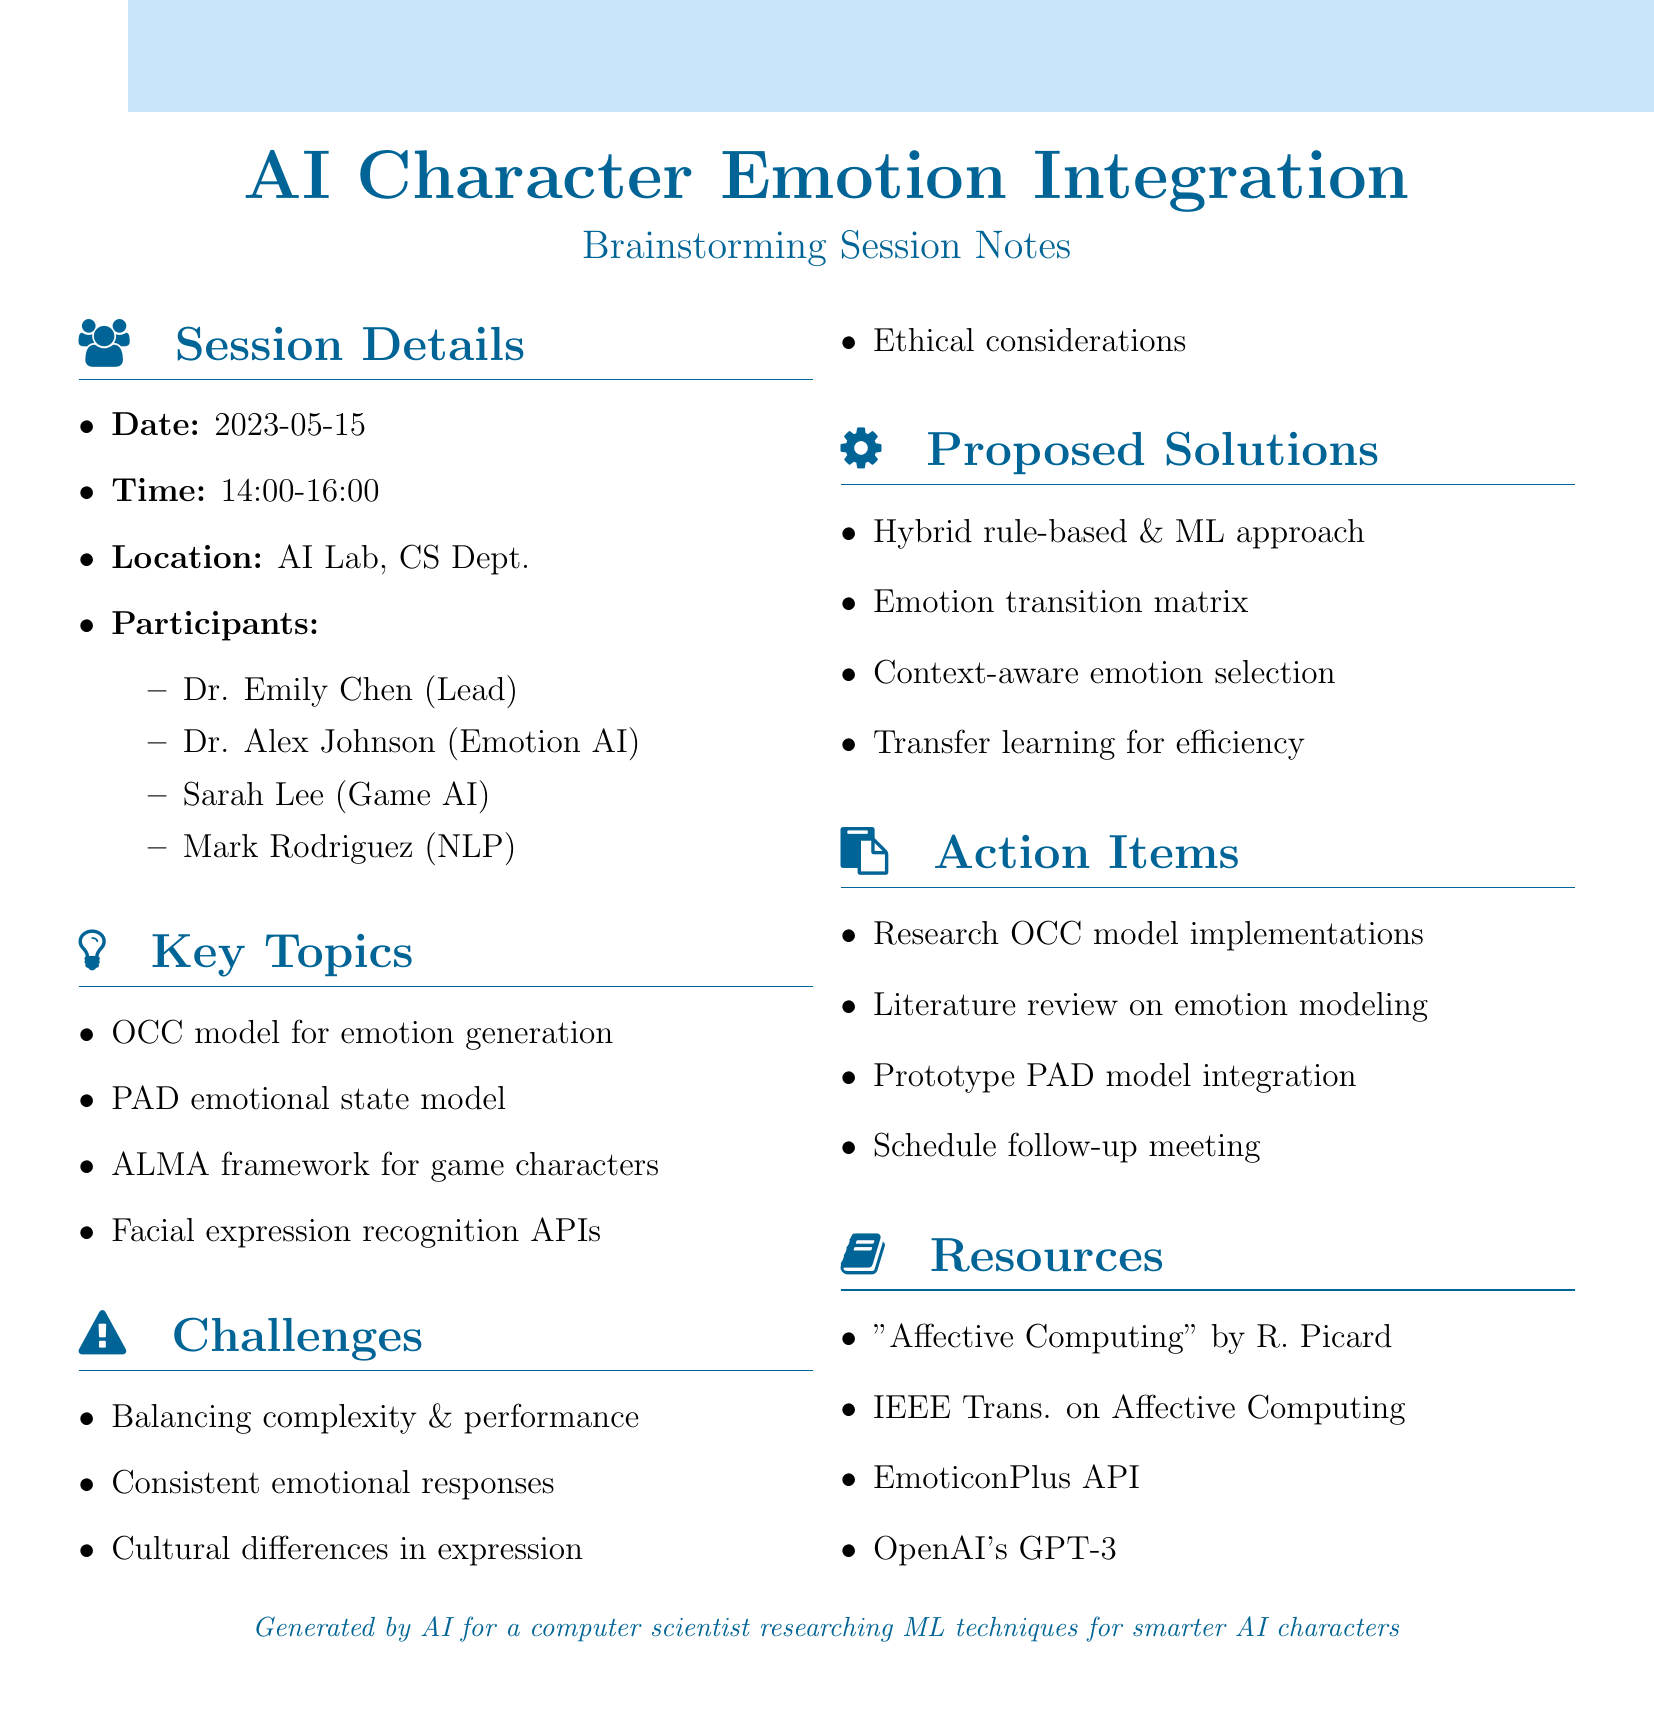what date was the brainstorming session held? The date of the session is listed in the document as May 15, 2023.
Answer: May 15, 2023 who was the lead researcher in the session? The document specifies Dr. Emily Chen as the lead researcher among the participants.
Answer: Dr. Emily Chen what is the main emotional model proposed for integration? The OCC model is highlighted as a key topic for emotion generation in AI characters.
Answer: OCC model what challenge involves cultural aspects? The document discusses challenges regarding handling cultural differences in emotional expression.
Answer: Cultural differences in expression how many participants attended the session? The list of participants indicates there are four individuals involved in the brainstorming session.
Answer: 4 what type of algorithm is proposed for emotion selection? The notes mention a context-aware emotion selection algorithm as one of the proposed solutions.
Answer: Context-aware emotion selection algorithm what resource is mentioned for exploring facial expression analysis? The document lists EmoticonPlus API as a resource to explore for facial expression analysis.
Answer: EmoticonPlus API which model is suggested for reducing computational load? The proposed solution includes using transfer learning from pre-trained emotion recognition models to enhance efficiency.
Answer: Transfer learning 